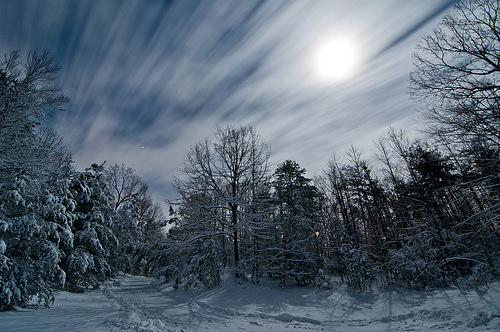<image>
Can you confirm if the tree is on the road? No. The tree is not positioned on the road. They may be near each other, but the tree is not supported by or resting on top of the road. 